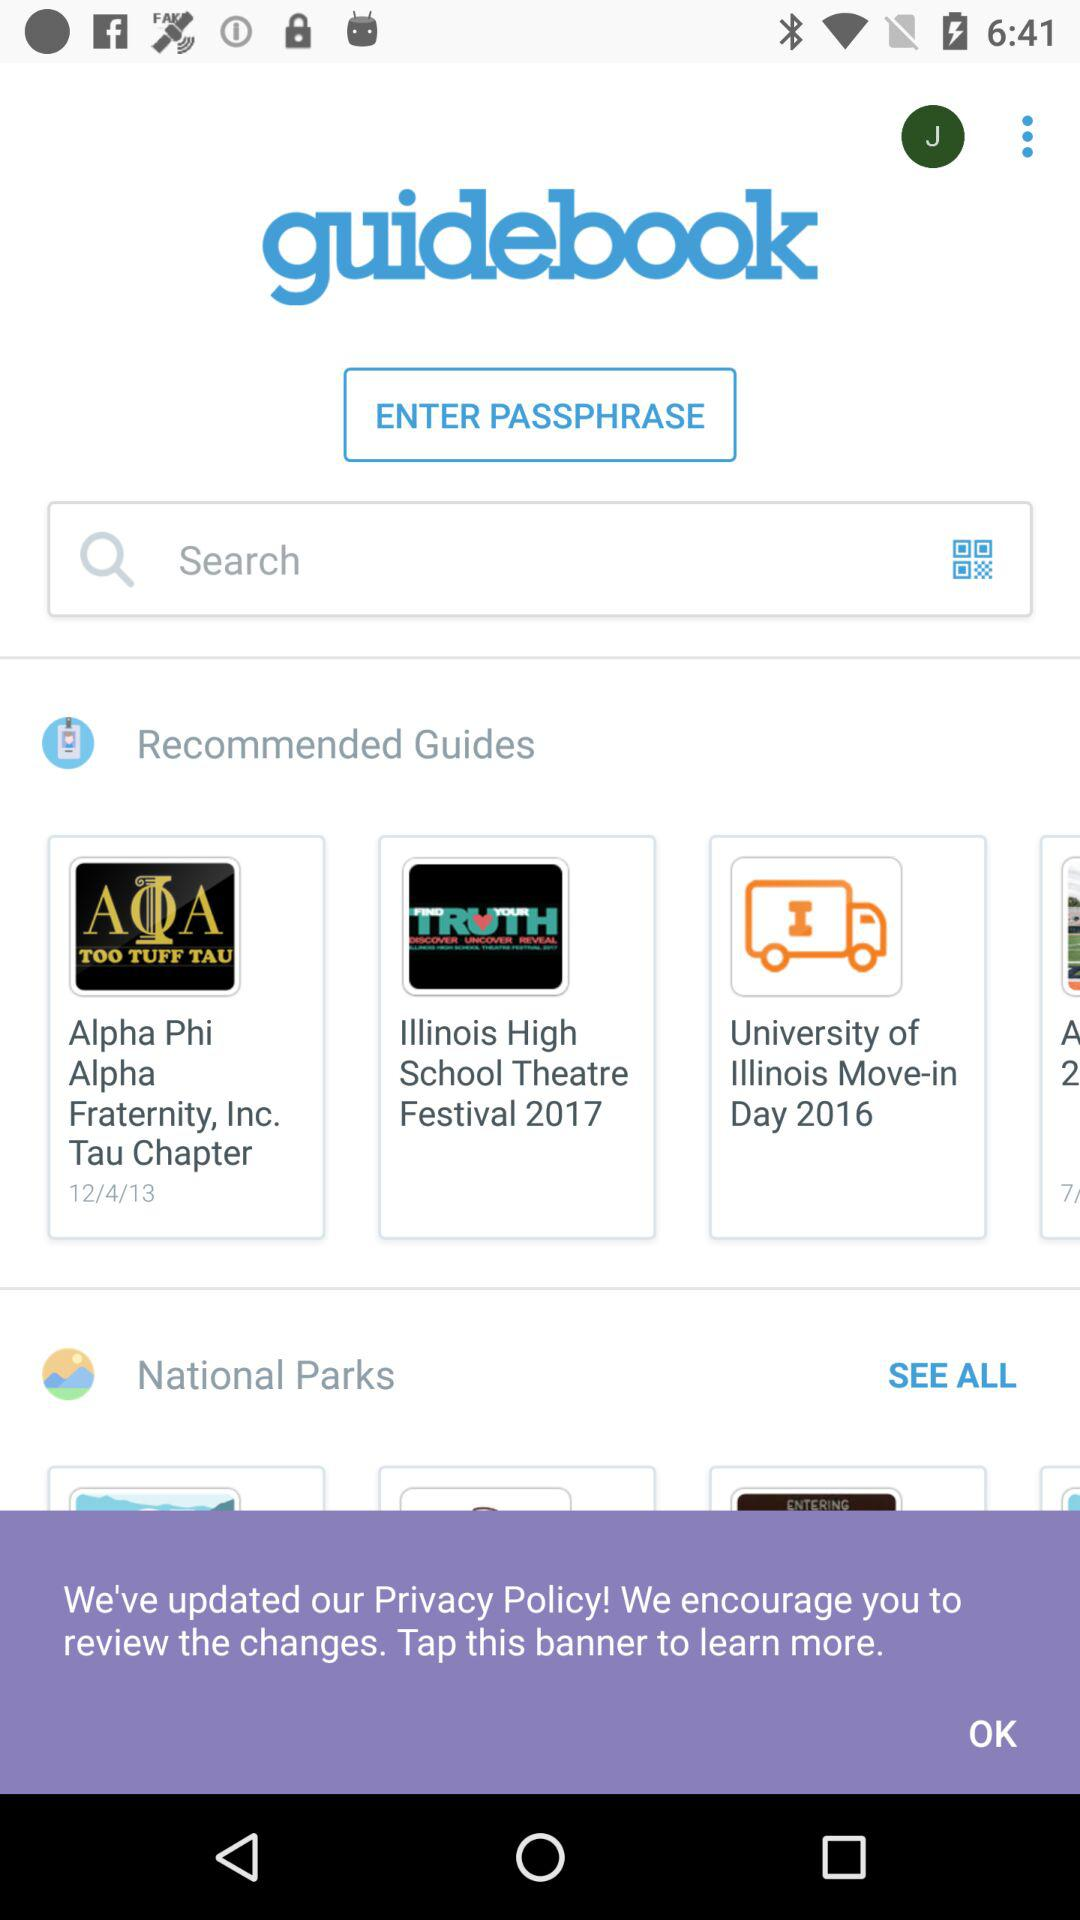What are some of the recommended guidebooks? Some of the recommended guidebooks are :"Alpha Phi Alpha Fraternity, Inc.Tau Chapter", "2017 Illinois High School Theatre Festival", and "University of Illinois Move-in Day 2016". 